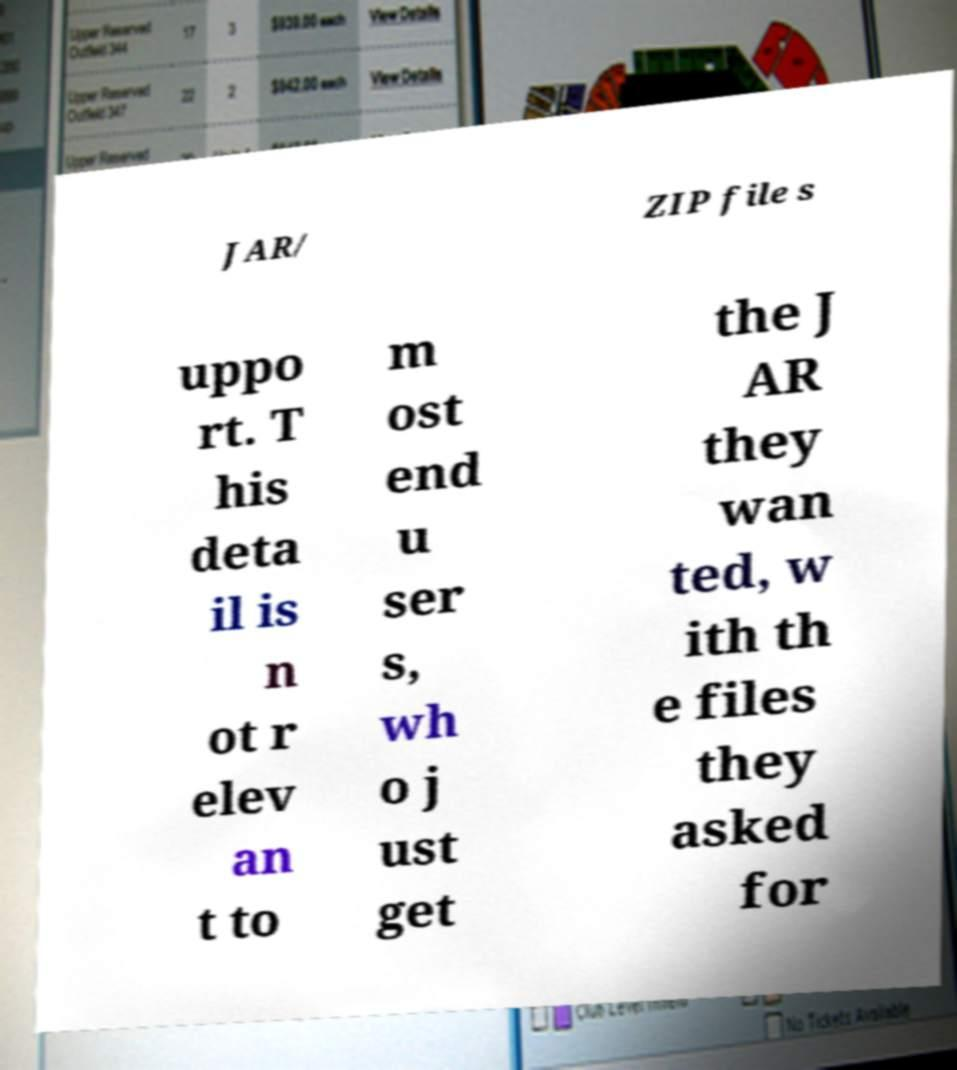For documentation purposes, I need the text within this image transcribed. Could you provide that? JAR/ ZIP file s uppo rt. T his deta il is n ot r elev an t to m ost end u ser s, wh o j ust get the J AR they wan ted, w ith th e files they asked for 